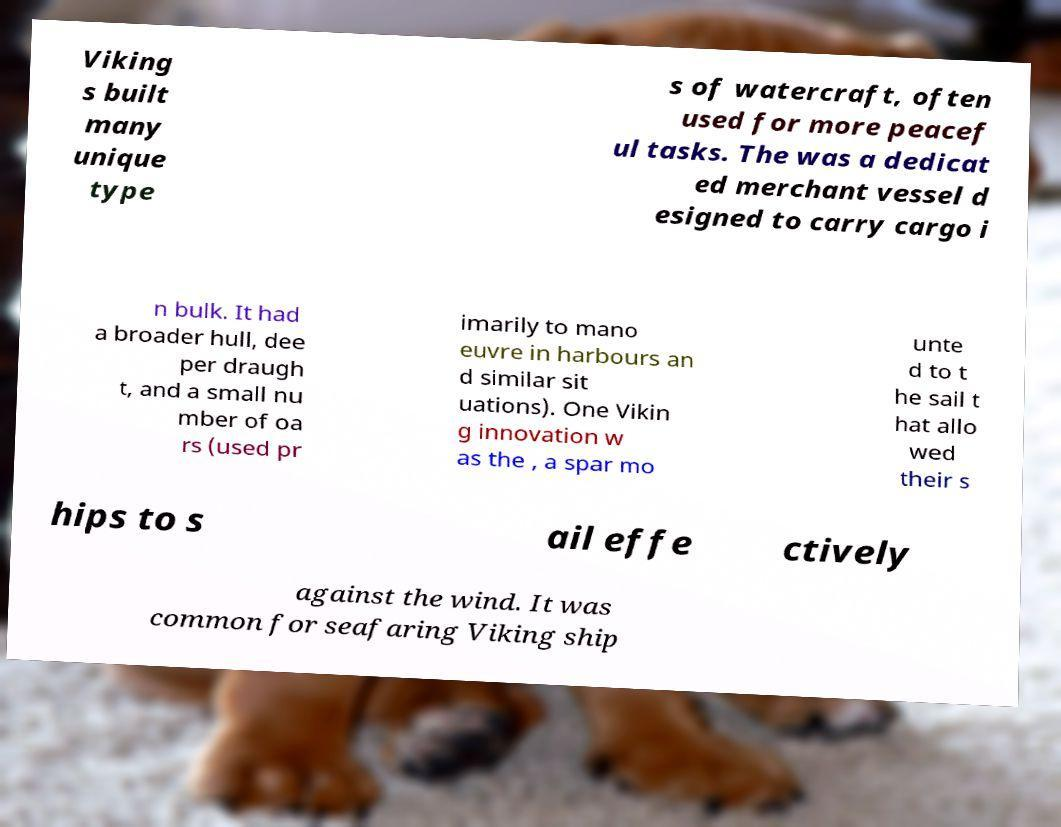What messages or text are displayed in this image? I need them in a readable, typed format. Viking s built many unique type s of watercraft, often used for more peacef ul tasks. The was a dedicat ed merchant vessel d esigned to carry cargo i n bulk. It had a broader hull, dee per draugh t, and a small nu mber of oa rs (used pr imarily to mano euvre in harbours an d similar sit uations). One Vikin g innovation w as the , a spar mo unte d to t he sail t hat allo wed their s hips to s ail effe ctively against the wind. It was common for seafaring Viking ship 